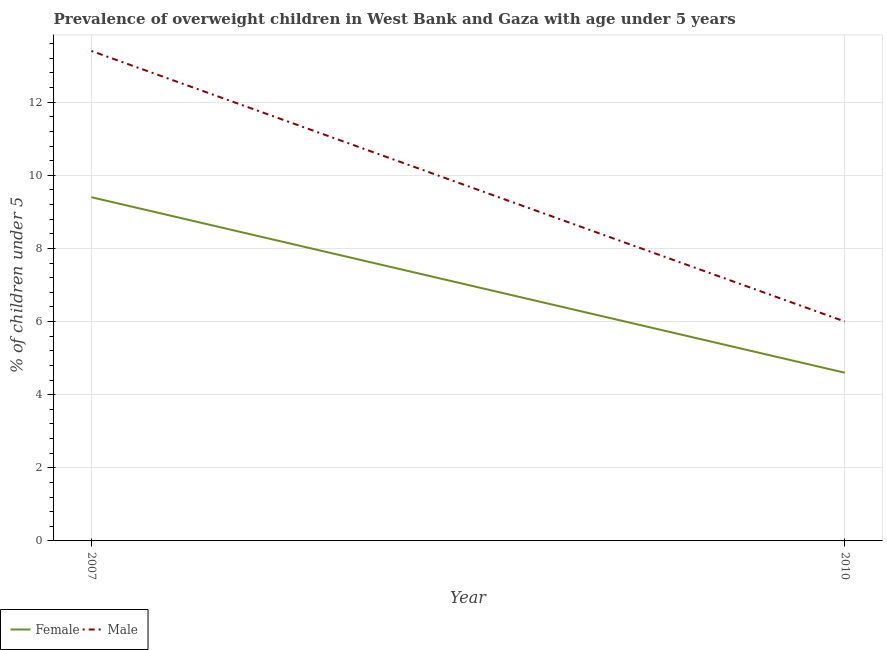How many different coloured lines are there?
Provide a short and direct response. 2. Does the line corresponding to percentage of obese male children intersect with the line corresponding to percentage of obese female children?
Make the answer very short. No. What is the percentage of obese female children in 2007?
Keep it short and to the point. 9.4. Across all years, what is the maximum percentage of obese male children?
Ensure brevity in your answer.  13.4. Across all years, what is the minimum percentage of obese male children?
Ensure brevity in your answer.  6. In which year was the percentage of obese male children minimum?
Provide a short and direct response. 2010. What is the total percentage of obese female children in the graph?
Offer a terse response. 14. What is the difference between the percentage of obese female children in 2007 and that in 2010?
Make the answer very short. 4.8. What is the difference between the percentage of obese female children in 2007 and the percentage of obese male children in 2010?
Your answer should be compact. 3.4. What is the average percentage of obese male children per year?
Offer a terse response. 9.7. In the year 2010, what is the difference between the percentage of obese male children and percentage of obese female children?
Give a very brief answer. 1.4. What is the ratio of the percentage of obese male children in 2007 to that in 2010?
Your answer should be compact. 2.23. How many lines are there?
Your response must be concise. 2. How many years are there in the graph?
Your answer should be compact. 2. Where does the legend appear in the graph?
Ensure brevity in your answer.  Bottom left. What is the title of the graph?
Make the answer very short. Prevalence of overweight children in West Bank and Gaza with age under 5 years. What is the label or title of the Y-axis?
Make the answer very short.  % of children under 5. What is the  % of children under 5 of Female in 2007?
Make the answer very short. 9.4. What is the  % of children under 5 of Male in 2007?
Your answer should be very brief. 13.4. What is the  % of children under 5 in Female in 2010?
Provide a succinct answer. 4.6. Across all years, what is the maximum  % of children under 5 of Female?
Provide a succinct answer. 9.4. Across all years, what is the maximum  % of children under 5 of Male?
Ensure brevity in your answer.  13.4. Across all years, what is the minimum  % of children under 5 of Female?
Provide a succinct answer. 4.6. Across all years, what is the minimum  % of children under 5 of Male?
Offer a terse response. 6. What is the total  % of children under 5 of Male in the graph?
Your response must be concise. 19.4. What is the difference between the  % of children under 5 in Male in 2007 and that in 2010?
Your answer should be compact. 7.4. What is the average  % of children under 5 of Female per year?
Provide a succinct answer. 7. What is the ratio of the  % of children under 5 of Female in 2007 to that in 2010?
Offer a terse response. 2.04. What is the ratio of the  % of children under 5 in Male in 2007 to that in 2010?
Offer a very short reply. 2.23. What is the difference between the highest and the second highest  % of children under 5 in Female?
Give a very brief answer. 4.8. What is the difference between the highest and the lowest  % of children under 5 in Male?
Make the answer very short. 7.4. 